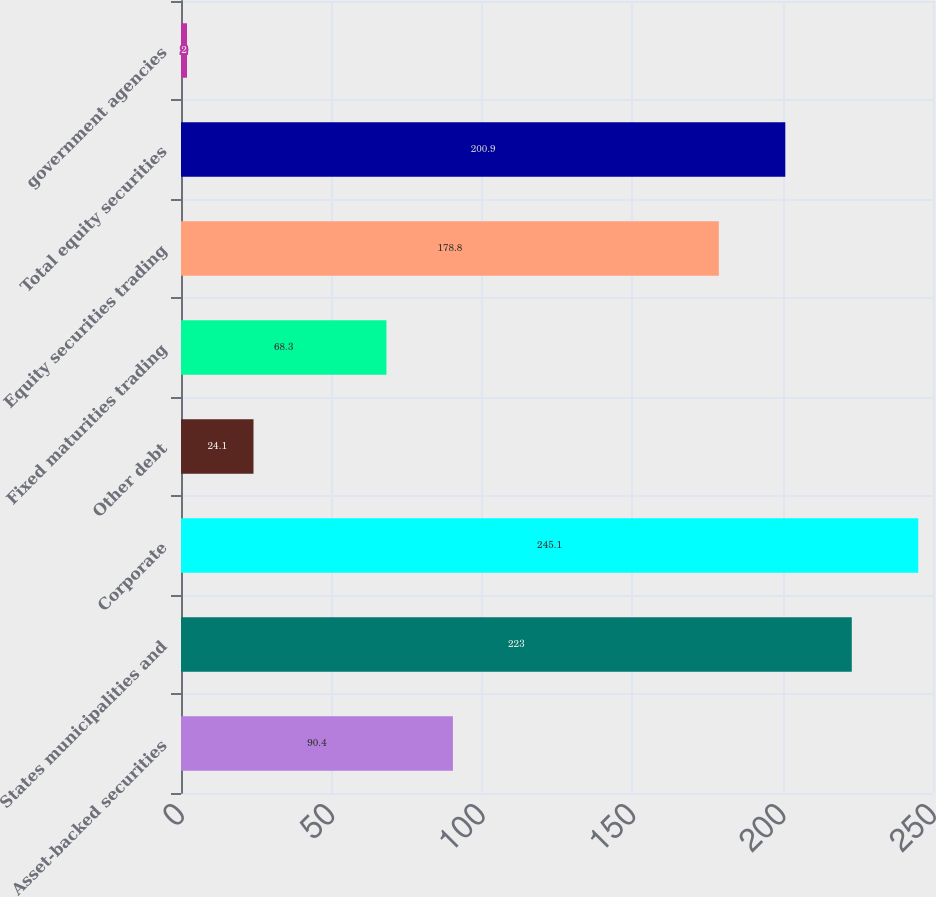Convert chart. <chart><loc_0><loc_0><loc_500><loc_500><bar_chart><fcel>Asset-backed securities<fcel>States municipalities and<fcel>Corporate<fcel>Other debt<fcel>Fixed maturities trading<fcel>Equity securities trading<fcel>Total equity securities<fcel>government agencies<nl><fcel>90.4<fcel>223<fcel>245.1<fcel>24.1<fcel>68.3<fcel>178.8<fcel>200.9<fcel>2<nl></chart> 